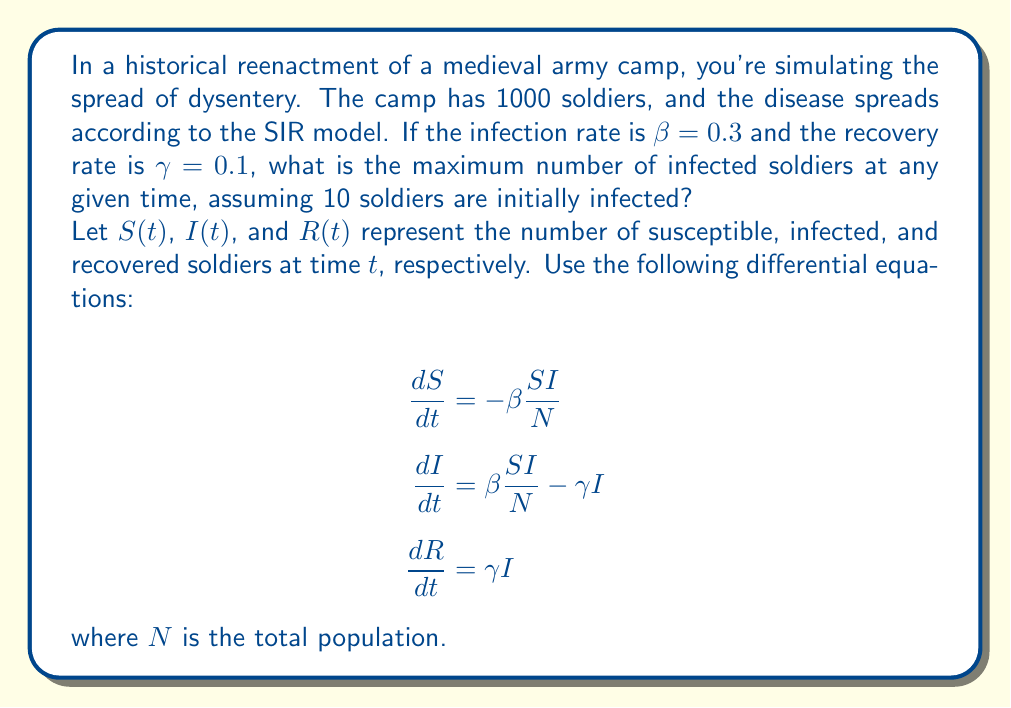Could you help me with this problem? To find the maximum number of infected soldiers, we need to determine when $\frac{dI}{dt} = 0$. This occurs when:

$$\beta \frac{SI}{N} - \gamma I = 0$$

Rearranging this equation:

$$\frac{S}{N} = \frac{\gamma}{\beta} = \frac{0.1}{0.3} = \frac{1}{3}$$

This means the number of susceptible soldiers at the peak of infection is:

$$S = \frac{1}{3}N = \frac{1}{3} \cdot 1000 = 333.33$$

Since $N = S + I + R$, and initially $R(0) = 0$, we can calculate $I$ at its peak:

$$I_{max} = N - S - R = 1000 - 333.33 - 0 = 666.67$$

However, since we're dealing with whole soldiers, we round down to 666.

To verify this is indeed the maximum, we can check that $\frac{dI}{dt} < 0$ for any larger value of $I$, and $\frac{dI}{dt} > 0$ for any smaller value of $I$ (excluding the initial condition).
Answer: 666 soldiers 